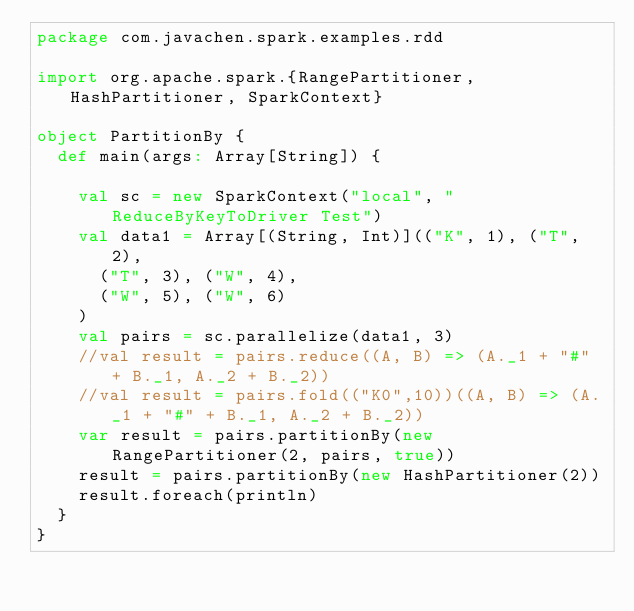<code> <loc_0><loc_0><loc_500><loc_500><_Scala_>package com.javachen.spark.examples.rdd

import org.apache.spark.{RangePartitioner,HashPartitioner, SparkContext}

object PartitionBy {
  def main(args: Array[String]) {

    val sc = new SparkContext("local", "ReduceByKeyToDriver Test")
    val data1 = Array[(String, Int)](("K", 1), ("T", 2),
      ("T", 3), ("W", 4),
      ("W", 5), ("W", 6)
    )
    val pairs = sc.parallelize(data1, 3)
    //val result = pairs.reduce((A, B) => (A._1 + "#" + B._1, A._2 + B._2))
    //val result = pairs.fold(("K0",10))((A, B) => (A._1 + "#" + B._1, A._2 + B._2))
    var result = pairs.partitionBy(new RangePartitioner(2, pairs, true))
    result = pairs.partitionBy(new HashPartitioner(2))
    result.foreach(println)
  }
}</code> 